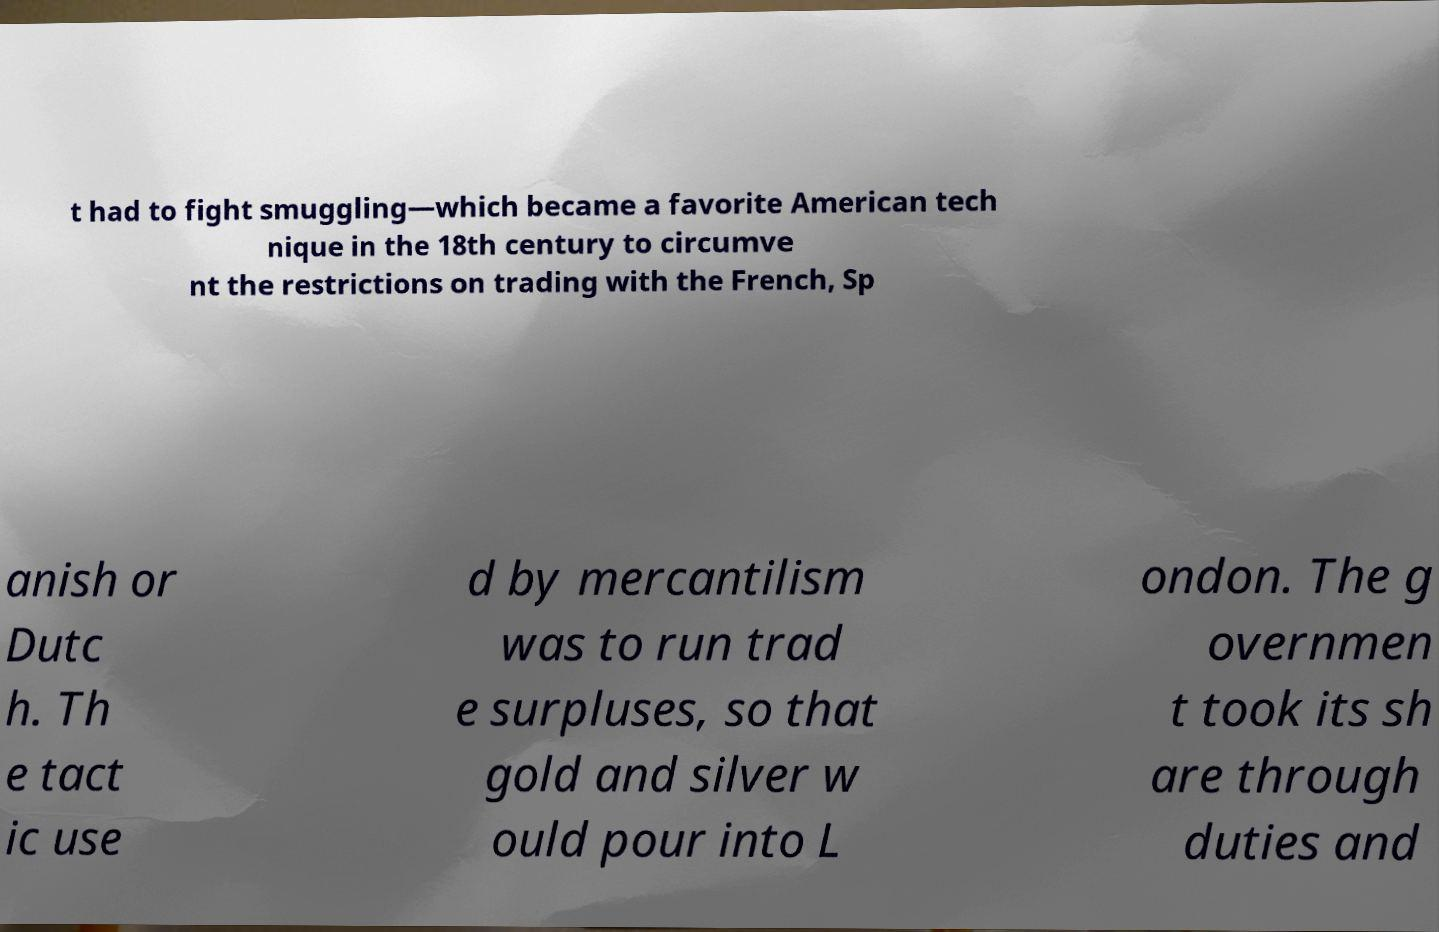What messages or text are displayed in this image? I need them in a readable, typed format. t had to fight smuggling—which became a favorite American tech nique in the 18th century to circumve nt the restrictions on trading with the French, Sp anish or Dutc h. Th e tact ic use d by mercantilism was to run trad e surpluses, so that gold and silver w ould pour into L ondon. The g overnmen t took its sh are through duties and 